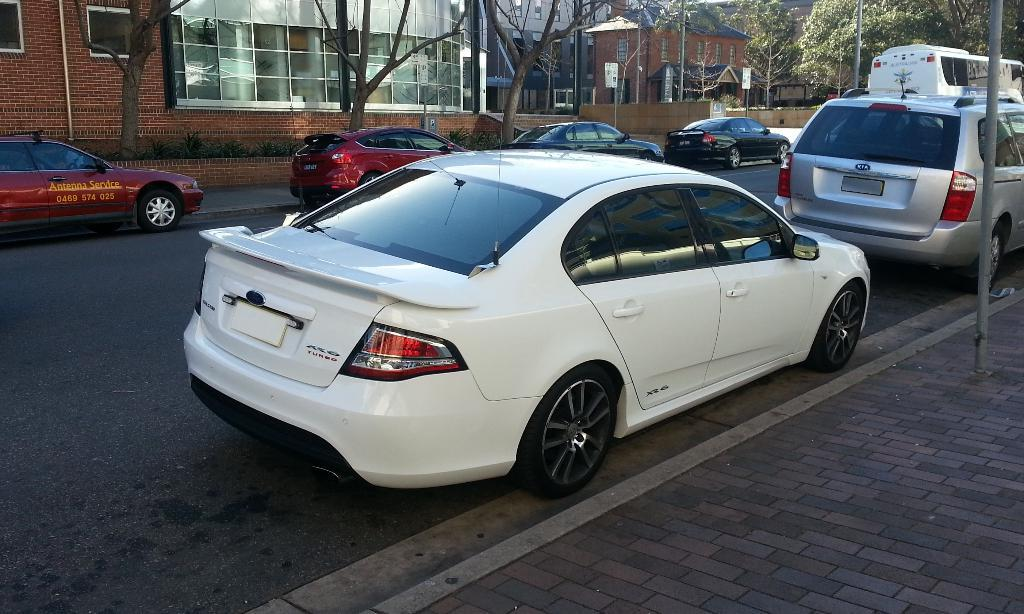What can be seen on the road in the image? There are cars parked on the road in the image. What is visible in the background of the image? There are trees and buildings visible in the background of the image. How many fingers can be seen pointing at the cars in the image? There are no fingers visible in the image, as it only shows parked cars on the road and the background. 